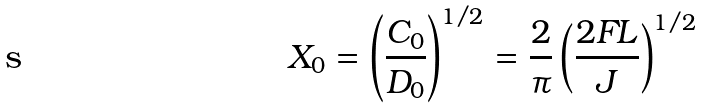Convert formula to latex. <formula><loc_0><loc_0><loc_500><loc_500>X _ { 0 } = \left ( \frac { C _ { 0 } } { D _ { 0 } } \right ) ^ { 1 / 2 } = \frac { 2 } { \pi } \left ( \frac { 2 F L } { J } \right ) ^ { 1 / 2 }</formula> 